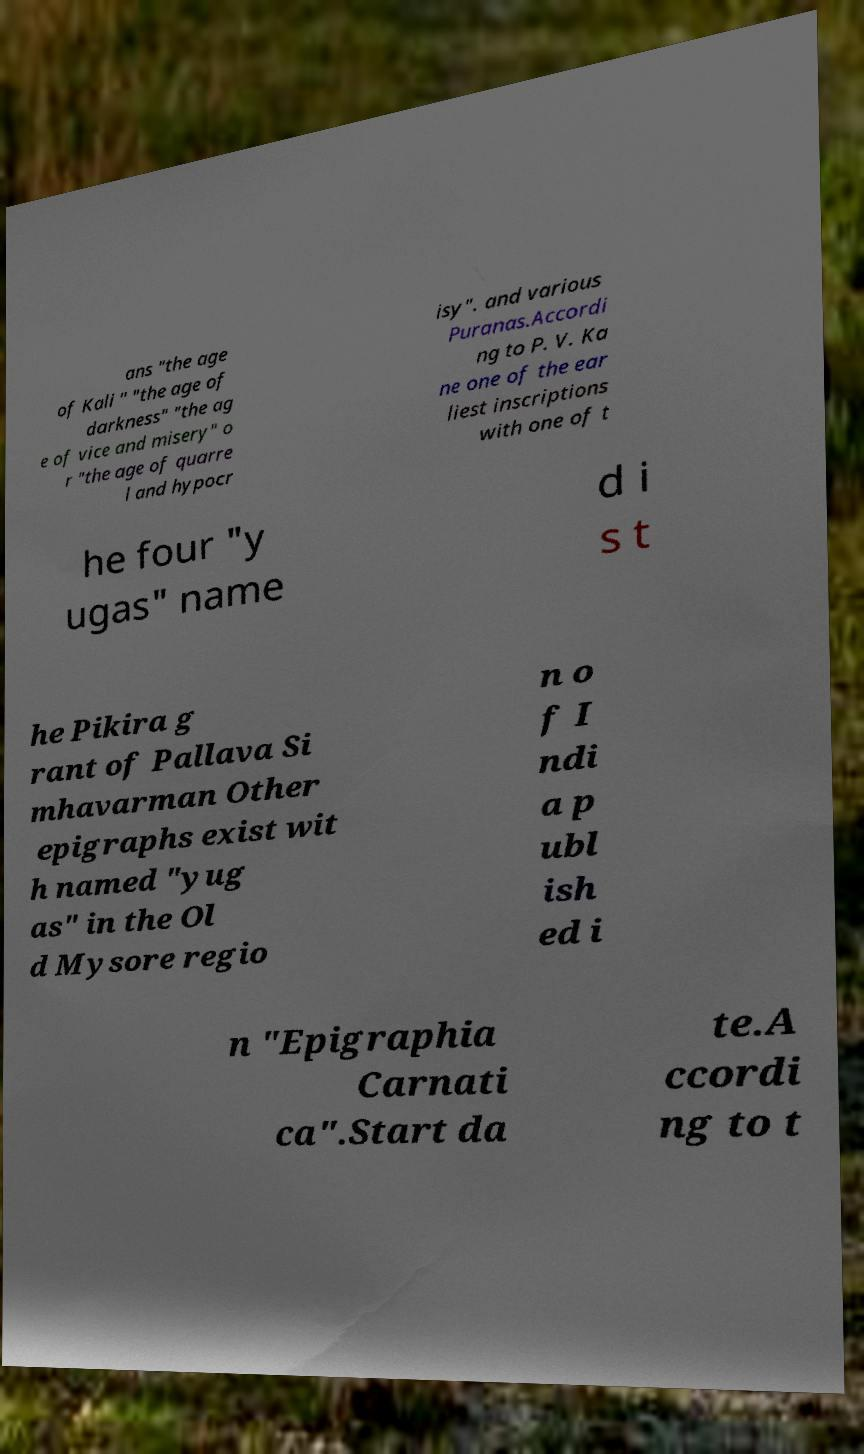Can you read and provide the text displayed in the image?This photo seems to have some interesting text. Can you extract and type it out for me? ans "the age of Kali " "the age of darkness" "the ag e of vice and misery" o r "the age of quarre l and hypocr isy". and various Puranas.Accordi ng to P. V. Ka ne one of the ear liest inscriptions with one of t he four "y ugas" name d i s t he Pikira g rant of Pallava Si mhavarman Other epigraphs exist wit h named "yug as" in the Ol d Mysore regio n o f I ndi a p ubl ish ed i n "Epigraphia Carnati ca".Start da te.A ccordi ng to t 